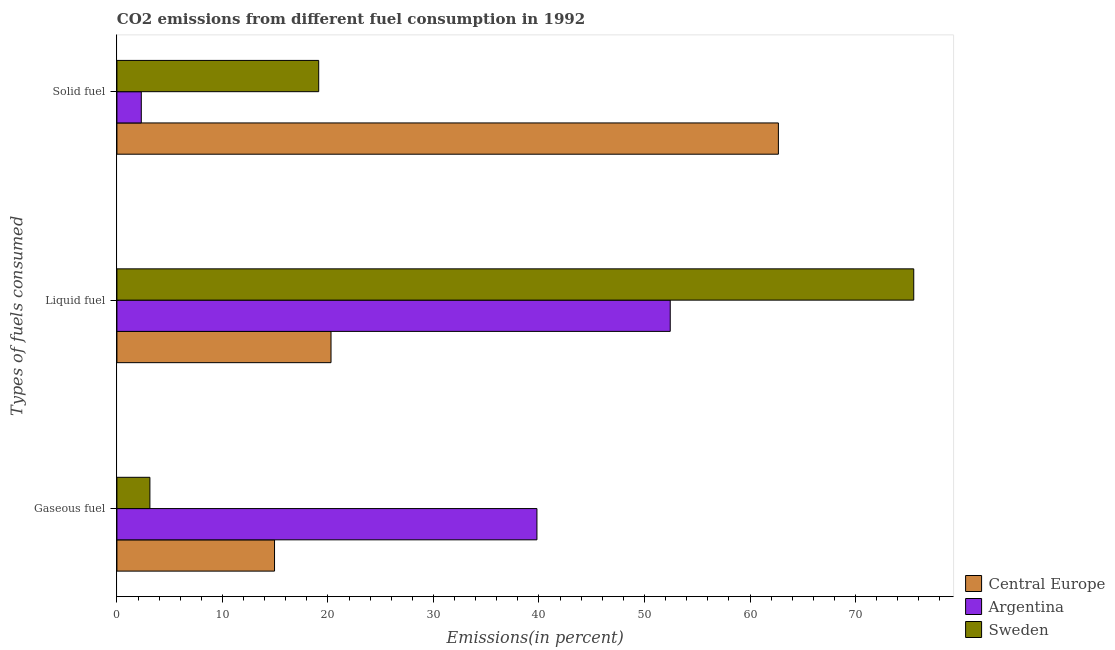Are the number of bars per tick equal to the number of legend labels?
Keep it short and to the point. Yes. How many bars are there on the 2nd tick from the bottom?
Provide a succinct answer. 3. What is the label of the 3rd group of bars from the top?
Offer a terse response. Gaseous fuel. What is the percentage of liquid fuel emission in Sweden?
Keep it short and to the point. 75.52. Across all countries, what is the maximum percentage of gaseous fuel emission?
Give a very brief answer. 39.8. Across all countries, what is the minimum percentage of solid fuel emission?
Give a very brief answer. 2.31. In which country was the percentage of gaseous fuel emission maximum?
Your answer should be very brief. Argentina. In which country was the percentage of liquid fuel emission minimum?
Offer a terse response. Central Europe. What is the total percentage of liquid fuel emission in the graph?
Make the answer very short. 148.24. What is the difference between the percentage of liquid fuel emission in Sweden and that in Argentina?
Keep it short and to the point. 23.08. What is the difference between the percentage of solid fuel emission in Sweden and the percentage of gaseous fuel emission in Central Europe?
Offer a terse response. 4.19. What is the average percentage of solid fuel emission per country?
Offer a very short reply. 28.04. What is the difference between the percentage of gaseous fuel emission and percentage of liquid fuel emission in Central Europe?
Keep it short and to the point. -5.35. What is the ratio of the percentage of gaseous fuel emission in Sweden to that in Central Europe?
Provide a short and direct response. 0.21. What is the difference between the highest and the second highest percentage of liquid fuel emission?
Offer a terse response. 23.08. What is the difference between the highest and the lowest percentage of liquid fuel emission?
Keep it short and to the point. 55.23. What does the 3rd bar from the bottom in Solid fuel represents?
Provide a short and direct response. Sweden. How many bars are there?
Provide a succinct answer. 9. How many countries are there in the graph?
Your answer should be compact. 3. Are the values on the major ticks of X-axis written in scientific E-notation?
Keep it short and to the point. No. Where does the legend appear in the graph?
Your response must be concise. Bottom right. How are the legend labels stacked?
Ensure brevity in your answer.  Vertical. What is the title of the graph?
Offer a terse response. CO2 emissions from different fuel consumption in 1992. What is the label or title of the X-axis?
Give a very brief answer. Emissions(in percent). What is the label or title of the Y-axis?
Make the answer very short. Types of fuels consumed. What is the Emissions(in percent) in Central Europe in Gaseous fuel?
Make the answer very short. 14.94. What is the Emissions(in percent) of Argentina in Gaseous fuel?
Provide a short and direct response. 39.8. What is the Emissions(in percent) of Sweden in Gaseous fuel?
Your answer should be compact. 3.13. What is the Emissions(in percent) of Central Europe in Liquid fuel?
Your answer should be very brief. 20.29. What is the Emissions(in percent) in Argentina in Liquid fuel?
Give a very brief answer. 52.44. What is the Emissions(in percent) in Sweden in Liquid fuel?
Keep it short and to the point. 75.52. What is the Emissions(in percent) of Central Europe in Solid fuel?
Provide a succinct answer. 62.69. What is the Emissions(in percent) in Argentina in Solid fuel?
Provide a succinct answer. 2.31. What is the Emissions(in percent) of Sweden in Solid fuel?
Ensure brevity in your answer.  19.12. Across all Types of fuels consumed, what is the maximum Emissions(in percent) in Central Europe?
Your answer should be compact. 62.69. Across all Types of fuels consumed, what is the maximum Emissions(in percent) in Argentina?
Make the answer very short. 52.44. Across all Types of fuels consumed, what is the maximum Emissions(in percent) of Sweden?
Offer a very short reply. 75.52. Across all Types of fuels consumed, what is the minimum Emissions(in percent) in Central Europe?
Make the answer very short. 14.94. Across all Types of fuels consumed, what is the minimum Emissions(in percent) in Argentina?
Offer a terse response. 2.31. Across all Types of fuels consumed, what is the minimum Emissions(in percent) in Sweden?
Keep it short and to the point. 3.13. What is the total Emissions(in percent) in Central Europe in the graph?
Keep it short and to the point. 97.92. What is the total Emissions(in percent) of Argentina in the graph?
Your answer should be very brief. 94.55. What is the total Emissions(in percent) in Sweden in the graph?
Give a very brief answer. 97.77. What is the difference between the Emissions(in percent) of Central Europe in Gaseous fuel and that in Liquid fuel?
Keep it short and to the point. -5.35. What is the difference between the Emissions(in percent) in Argentina in Gaseous fuel and that in Liquid fuel?
Offer a very short reply. -12.63. What is the difference between the Emissions(in percent) in Sweden in Gaseous fuel and that in Liquid fuel?
Provide a succinct answer. -72.39. What is the difference between the Emissions(in percent) in Central Europe in Gaseous fuel and that in Solid fuel?
Offer a very short reply. -47.75. What is the difference between the Emissions(in percent) in Argentina in Gaseous fuel and that in Solid fuel?
Your answer should be very brief. 37.5. What is the difference between the Emissions(in percent) in Sweden in Gaseous fuel and that in Solid fuel?
Provide a succinct answer. -16. What is the difference between the Emissions(in percent) of Central Europe in Liquid fuel and that in Solid fuel?
Offer a terse response. -42.4. What is the difference between the Emissions(in percent) of Argentina in Liquid fuel and that in Solid fuel?
Your response must be concise. 50.13. What is the difference between the Emissions(in percent) in Sweden in Liquid fuel and that in Solid fuel?
Offer a terse response. 56.39. What is the difference between the Emissions(in percent) of Central Europe in Gaseous fuel and the Emissions(in percent) of Argentina in Liquid fuel?
Your response must be concise. -37.5. What is the difference between the Emissions(in percent) in Central Europe in Gaseous fuel and the Emissions(in percent) in Sweden in Liquid fuel?
Your answer should be very brief. -60.58. What is the difference between the Emissions(in percent) in Argentina in Gaseous fuel and the Emissions(in percent) in Sweden in Liquid fuel?
Provide a succinct answer. -35.71. What is the difference between the Emissions(in percent) in Central Europe in Gaseous fuel and the Emissions(in percent) in Argentina in Solid fuel?
Your answer should be very brief. 12.63. What is the difference between the Emissions(in percent) in Central Europe in Gaseous fuel and the Emissions(in percent) in Sweden in Solid fuel?
Give a very brief answer. -4.19. What is the difference between the Emissions(in percent) of Argentina in Gaseous fuel and the Emissions(in percent) of Sweden in Solid fuel?
Provide a succinct answer. 20.68. What is the difference between the Emissions(in percent) in Central Europe in Liquid fuel and the Emissions(in percent) in Argentina in Solid fuel?
Your response must be concise. 17.98. What is the difference between the Emissions(in percent) in Central Europe in Liquid fuel and the Emissions(in percent) in Sweden in Solid fuel?
Offer a terse response. 1.17. What is the difference between the Emissions(in percent) in Argentina in Liquid fuel and the Emissions(in percent) in Sweden in Solid fuel?
Offer a terse response. 33.31. What is the average Emissions(in percent) in Central Europe per Types of fuels consumed?
Make the answer very short. 32.64. What is the average Emissions(in percent) in Argentina per Types of fuels consumed?
Your response must be concise. 31.52. What is the average Emissions(in percent) of Sweden per Types of fuels consumed?
Provide a succinct answer. 32.59. What is the difference between the Emissions(in percent) in Central Europe and Emissions(in percent) in Argentina in Gaseous fuel?
Your response must be concise. -24.87. What is the difference between the Emissions(in percent) in Central Europe and Emissions(in percent) in Sweden in Gaseous fuel?
Ensure brevity in your answer.  11.81. What is the difference between the Emissions(in percent) of Argentina and Emissions(in percent) of Sweden in Gaseous fuel?
Keep it short and to the point. 36.68. What is the difference between the Emissions(in percent) of Central Europe and Emissions(in percent) of Argentina in Liquid fuel?
Your answer should be very brief. -32.15. What is the difference between the Emissions(in percent) in Central Europe and Emissions(in percent) in Sweden in Liquid fuel?
Provide a short and direct response. -55.23. What is the difference between the Emissions(in percent) in Argentina and Emissions(in percent) in Sweden in Liquid fuel?
Your answer should be very brief. -23.08. What is the difference between the Emissions(in percent) in Central Europe and Emissions(in percent) in Argentina in Solid fuel?
Offer a terse response. 60.38. What is the difference between the Emissions(in percent) of Central Europe and Emissions(in percent) of Sweden in Solid fuel?
Give a very brief answer. 43.57. What is the difference between the Emissions(in percent) of Argentina and Emissions(in percent) of Sweden in Solid fuel?
Give a very brief answer. -16.81. What is the ratio of the Emissions(in percent) in Central Europe in Gaseous fuel to that in Liquid fuel?
Give a very brief answer. 0.74. What is the ratio of the Emissions(in percent) of Argentina in Gaseous fuel to that in Liquid fuel?
Give a very brief answer. 0.76. What is the ratio of the Emissions(in percent) of Sweden in Gaseous fuel to that in Liquid fuel?
Offer a very short reply. 0.04. What is the ratio of the Emissions(in percent) of Central Europe in Gaseous fuel to that in Solid fuel?
Ensure brevity in your answer.  0.24. What is the ratio of the Emissions(in percent) of Argentina in Gaseous fuel to that in Solid fuel?
Your response must be concise. 17.23. What is the ratio of the Emissions(in percent) in Sweden in Gaseous fuel to that in Solid fuel?
Give a very brief answer. 0.16. What is the ratio of the Emissions(in percent) in Central Europe in Liquid fuel to that in Solid fuel?
Your answer should be compact. 0.32. What is the ratio of the Emissions(in percent) in Argentina in Liquid fuel to that in Solid fuel?
Ensure brevity in your answer.  22.7. What is the ratio of the Emissions(in percent) of Sweden in Liquid fuel to that in Solid fuel?
Give a very brief answer. 3.95. What is the difference between the highest and the second highest Emissions(in percent) of Central Europe?
Your answer should be compact. 42.4. What is the difference between the highest and the second highest Emissions(in percent) in Argentina?
Ensure brevity in your answer.  12.63. What is the difference between the highest and the second highest Emissions(in percent) of Sweden?
Your answer should be very brief. 56.39. What is the difference between the highest and the lowest Emissions(in percent) in Central Europe?
Your answer should be compact. 47.75. What is the difference between the highest and the lowest Emissions(in percent) of Argentina?
Your response must be concise. 50.13. What is the difference between the highest and the lowest Emissions(in percent) in Sweden?
Provide a succinct answer. 72.39. 